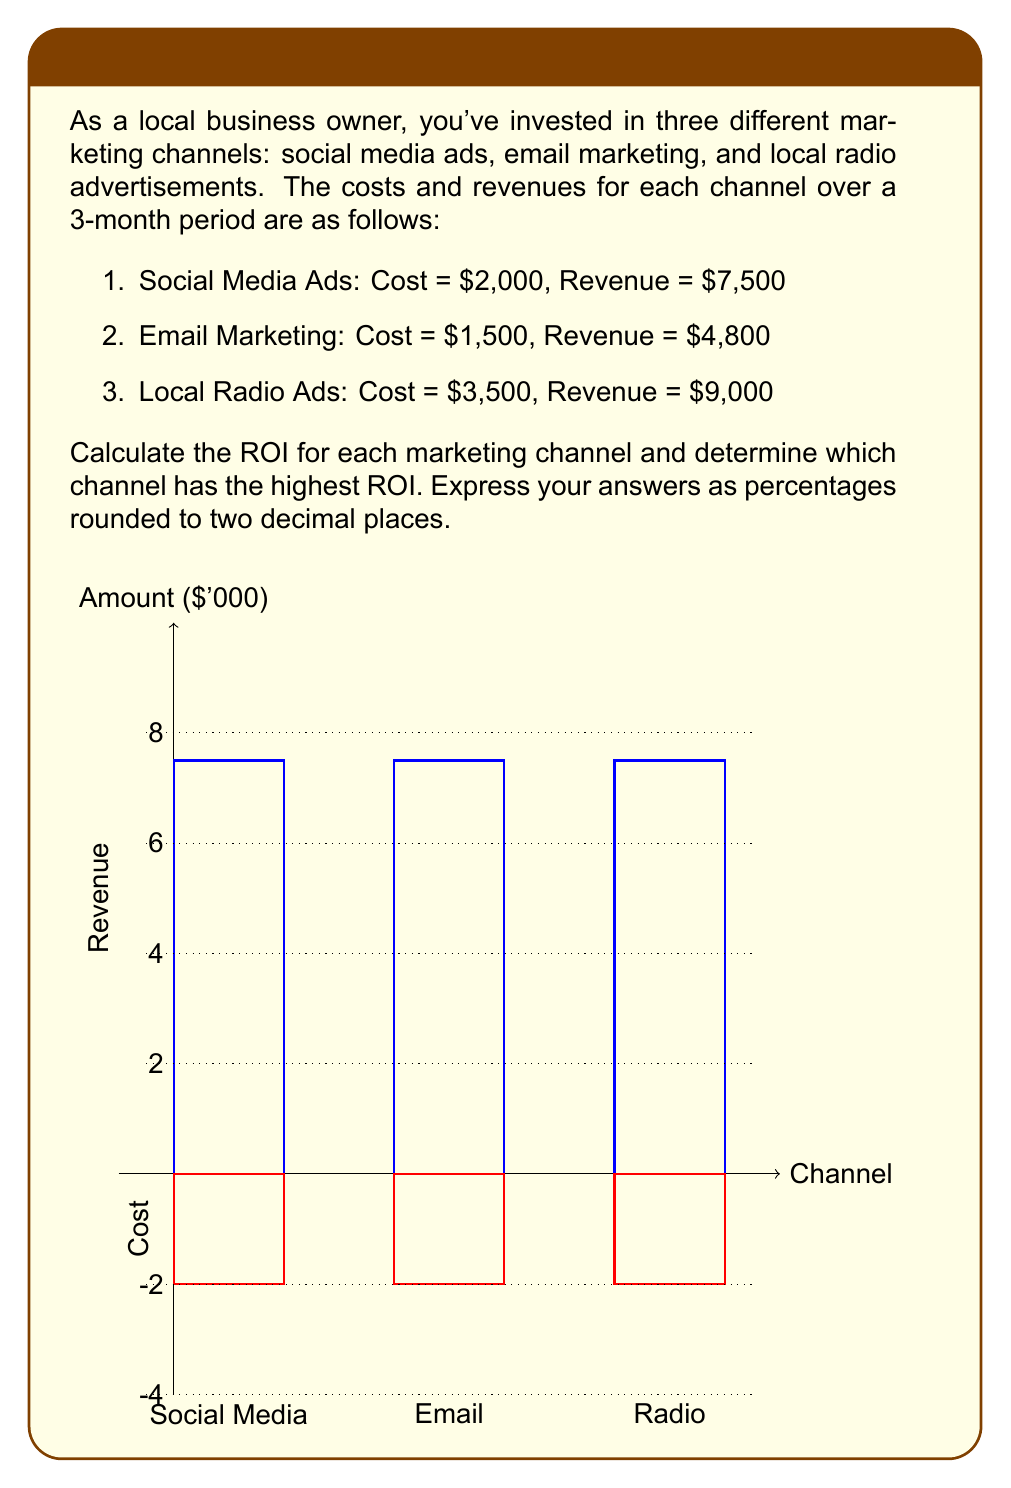Give your solution to this math problem. To calculate the ROI for each marketing channel, we'll use the formula:

$$ ROI = \frac{\text{Net Profit}}{\text{Cost of Investment}} \times 100\% $$

Where Net Profit is the difference between Revenue and Cost.

1. Social Media Ads:
   Net Profit = $7,500 - $2,000 = $5,500
   $$ ROI_{social} = \frac{5500}{2000} \times 100\% = 275.00\% $$

2. Email Marketing:
   Net Profit = $4,800 - $1,500 = $3,300
   $$ ROI_{email} = \frac{3300}{1500} \times 100\% = 220.00\% $$

3. Local Radio Ads:
   Net Profit = $9,000 - $3,500 = $5,500
   $$ ROI_{radio} = \frac{5500}{3500} \times 100\% = 157.14\% $$

Comparing the ROIs:
Social Media Ads: 275.00%
Email Marketing: 220.00%
Local Radio Ads: 157.14%

The highest ROI is from Social Media Ads at 275.00%.
Answer: Social Media: 275.00%, Email: 220.00%, Radio: 157.14%. Highest ROI: Social Media (275.00%). 